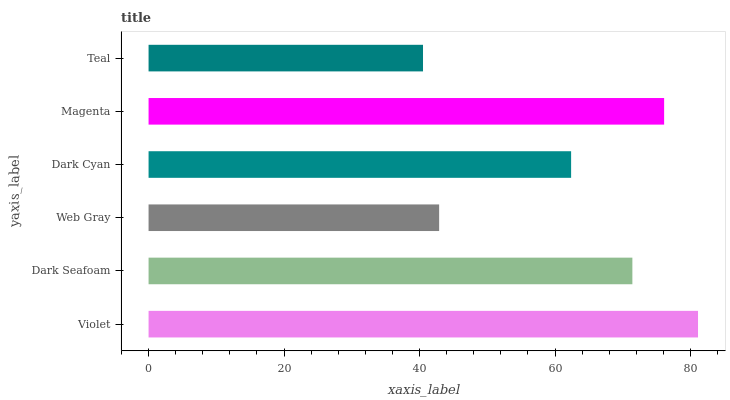Is Teal the minimum?
Answer yes or no. Yes. Is Violet the maximum?
Answer yes or no. Yes. Is Dark Seafoam the minimum?
Answer yes or no. No. Is Dark Seafoam the maximum?
Answer yes or no. No. Is Violet greater than Dark Seafoam?
Answer yes or no. Yes. Is Dark Seafoam less than Violet?
Answer yes or no. Yes. Is Dark Seafoam greater than Violet?
Answer yes or no. No. Is Violet less than Dark Seafoam?
Answer yes or no. No. Is Dark Seafoam the high median?
Answer yes or no. Yes. Is Dark Cyan the low median?
Answer yes or no. Yes. Is Violet the high median?
Answer yes or no. No. Is Teal the low median?
Answer yes or no. No. 